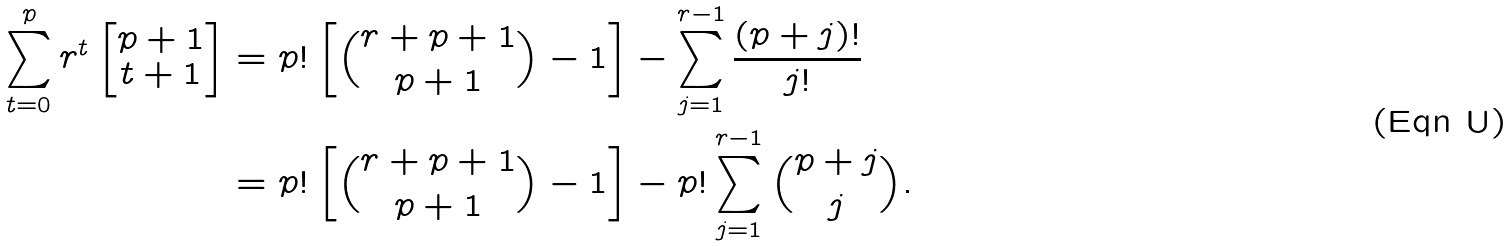Convert formula to latex. <formula><loc_0><loc_0><loc_500><loc_500>\sum _ { t = 0 } ^ { p } r ^ { t } \begin{bmatrix} p + 1 \\ t + 1 \end{bmatrix} & = p ! \left [ \binom { r + p + 1 } { p + 1 } - 1 \right ] - \sum _ { j = 1 } ^ { r - 1 } \frac { ( p + j ) ! } { j ! } \\ & = p ! \left [ \binom { r + p + 1 } { p + 1 } - 1 \right ] - p ! \sum _ { j = 1 } ^ { r - 1 } \binom { p + j } { j } .</formula> 